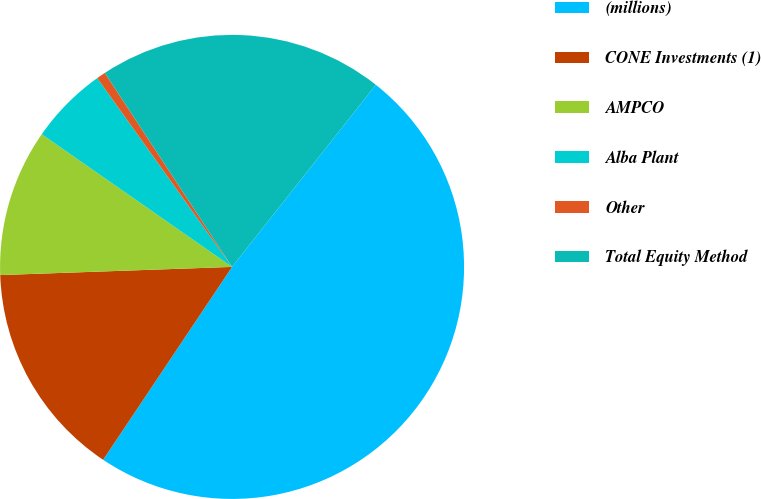Convert chart. <chart><loc_0><loc_0><loc_500><loc_500><pie_chart><fcel>(millions)<fcel>CONE Investments (1)<fcel>AMPCO<fcel>Alba Plant<fcel>Other<fcel>Total Equity Method<nl><fcel>48.74%<fcel>15.06%<fcel>10.25%<fcel>5.44%<fcel>0.63%<fcel>19.87%<nl></chart> 